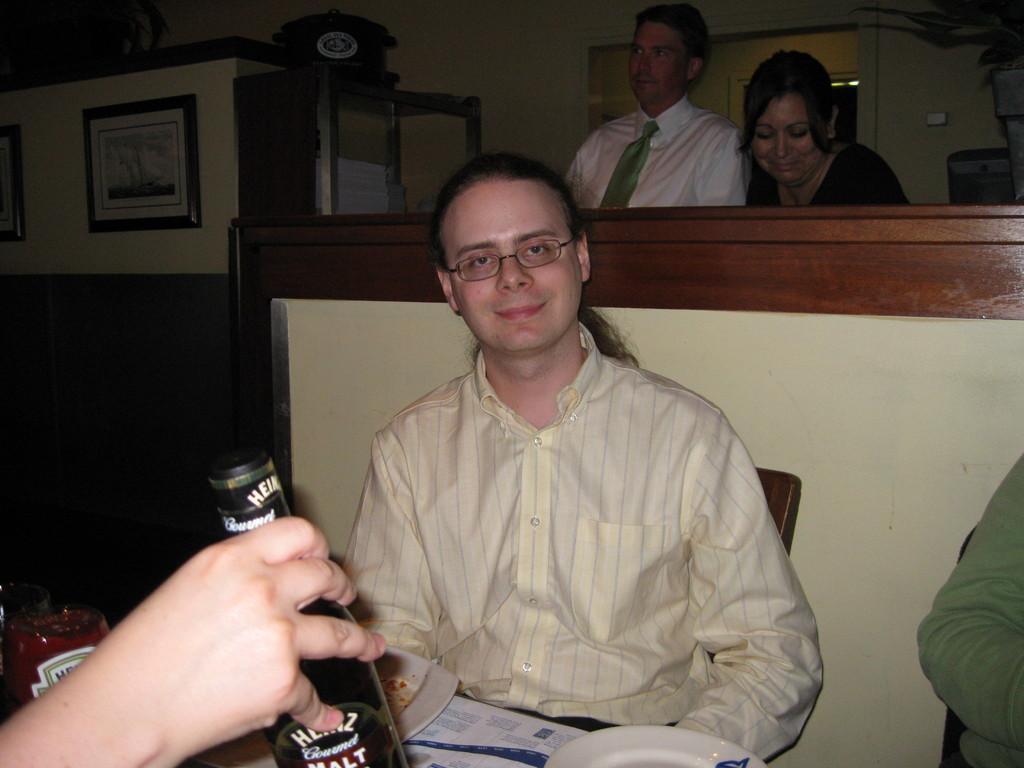Could you give a brief overview of what you see in this image? Here we can see a man sitting on the chair, and in front here is the table and wine bottle and some objects on it, and at back here are the persons standing. 